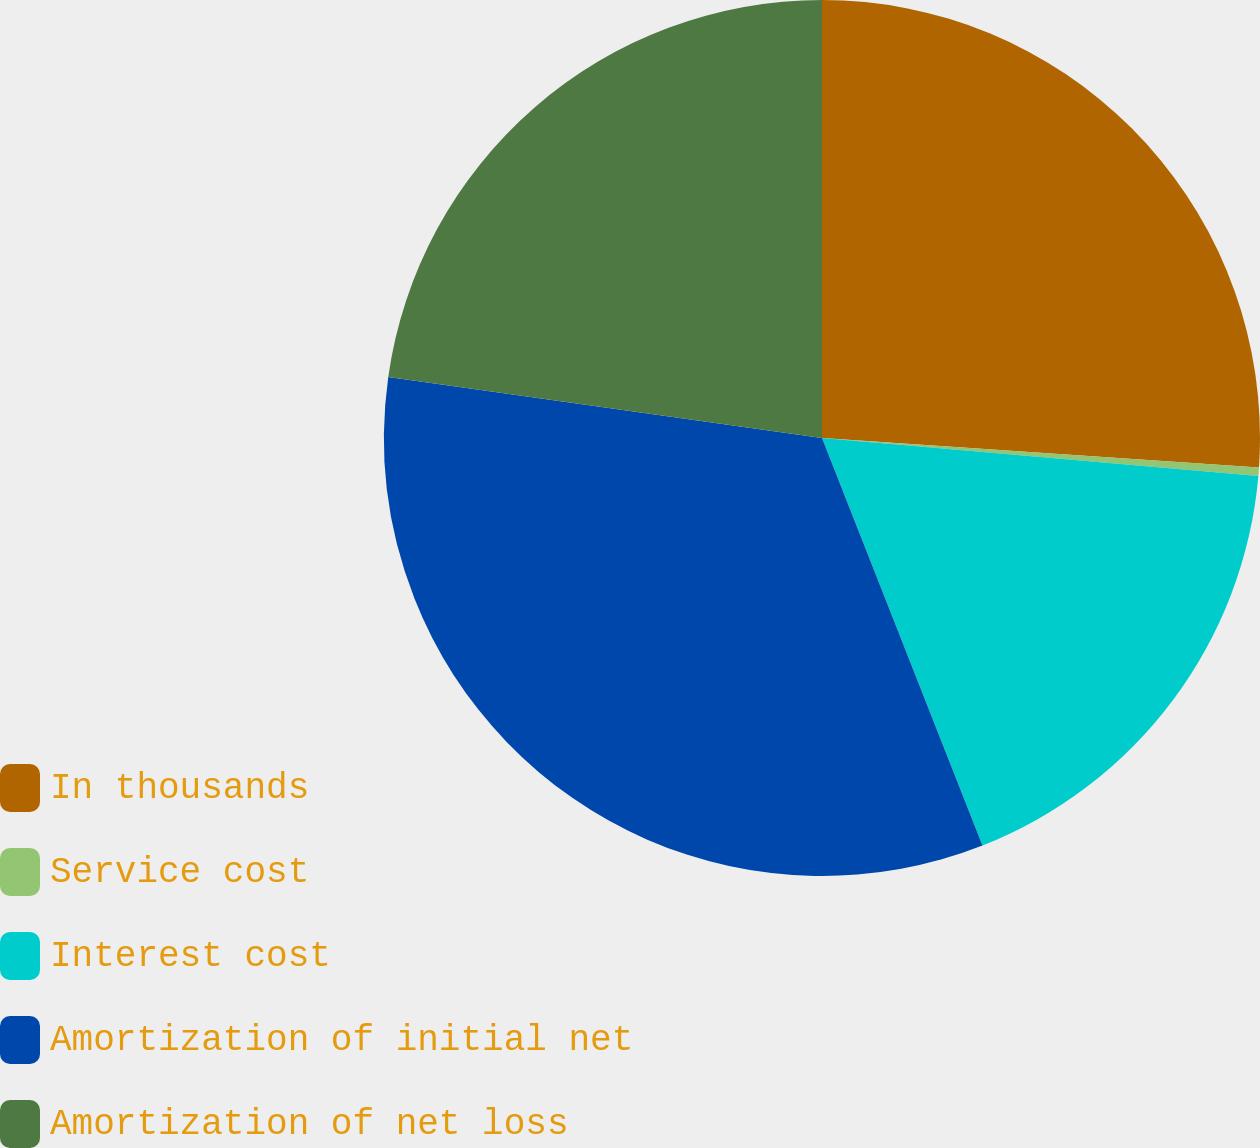Convert chart to OTSL. <chart><loc_0><loc_0><loc_500><loc_500><pie_chart><fcel>In thousands<fcel>Service cost<fcel>Interest cost<fcel>Amortization of initial net<fcel>Amortization of net loss<nl><fcel>26.07%<fcel>0.31%<fcel>17.65%<fcel>33.19%<fcel>22.78%<nl></chart> 